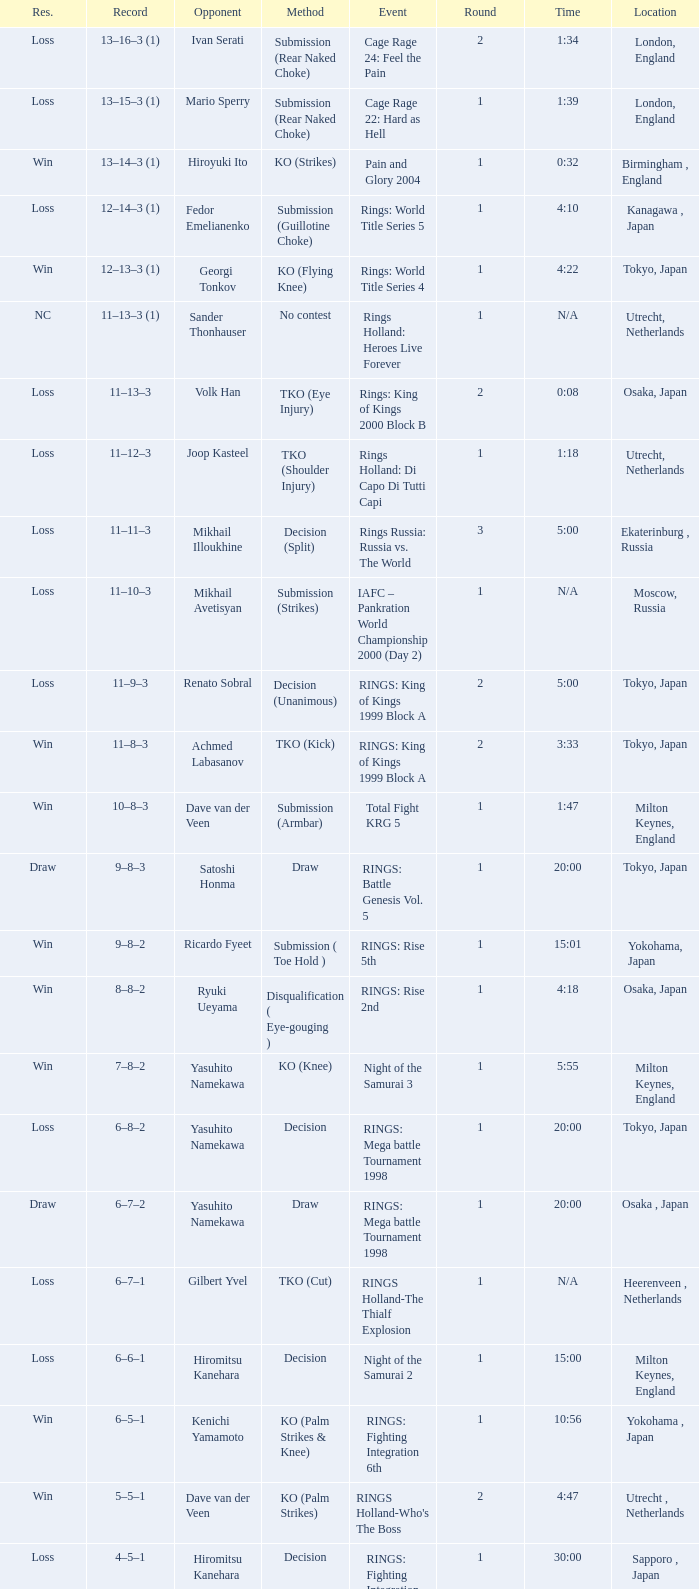What is the time for Moscow, Russia? N/A. 